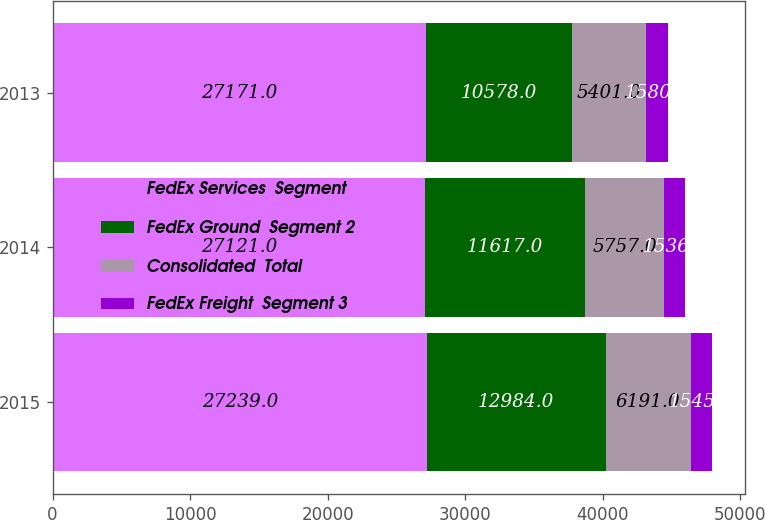<chart> <loc_0><loc_0><loc_500><loc_500><stacked_bar_chart><ecel><fcel>2015<fcel>2014<fcel>2013<nl><fcel>FedEx Services  Segment<fcel>27239<fcel>27121<fcel>27171<nl><fcel>FedEx Ground  Segment 2<fcel>12984<fcel>11617<fcel>10578<nl><fcel>Consolidated  Total<fcel>6191<fcel>5757<fcel>5401<nl><fcel>FedEx Freight  Segment 3<fcel>1545<fcel>1536<fcel>1580<nl></chart> 